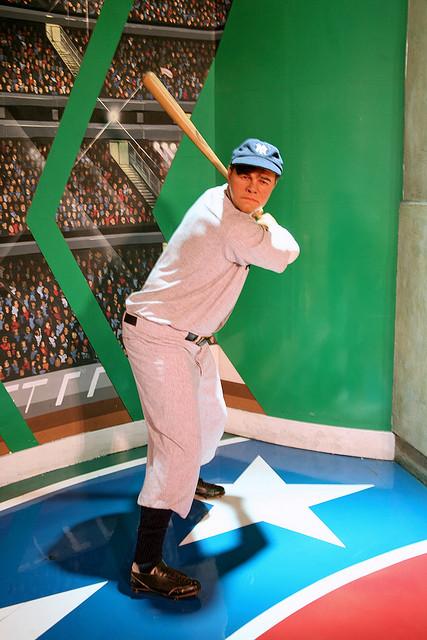Is this a real person?
Quick response, please. No. Why is the man holding a bat?
Short answer required. Posing. What game is the man playing?
Give a very brief answer. Baseball. 